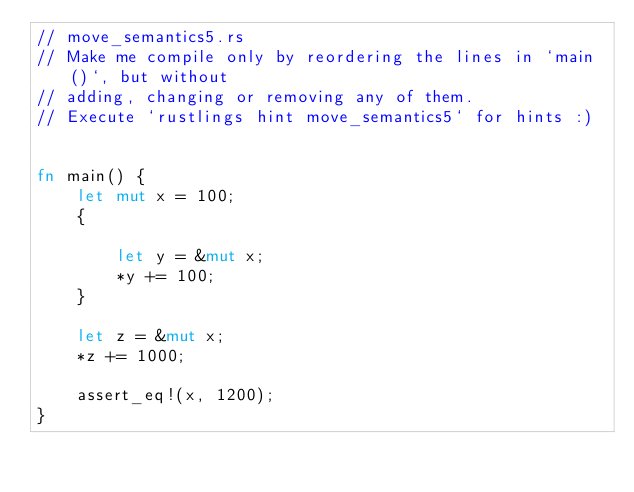<code> <loc_0><loc_0><loc_500><loc_500><_Rust_>// move_semantics5.rs
// Make me compile only by reordering the lines in `main()`, but without
// adding, changing or removing any of them.
// Execute `rustlings hint move_semantics5` for hints :)


fn main() {
    let mut x = 100;
    {
        
        let y = &mut x;
        *y += 100;  
    }

    let z = &mut x;
    *z += 1000;

    assert_eq!(x, 1200);
}
</code> 